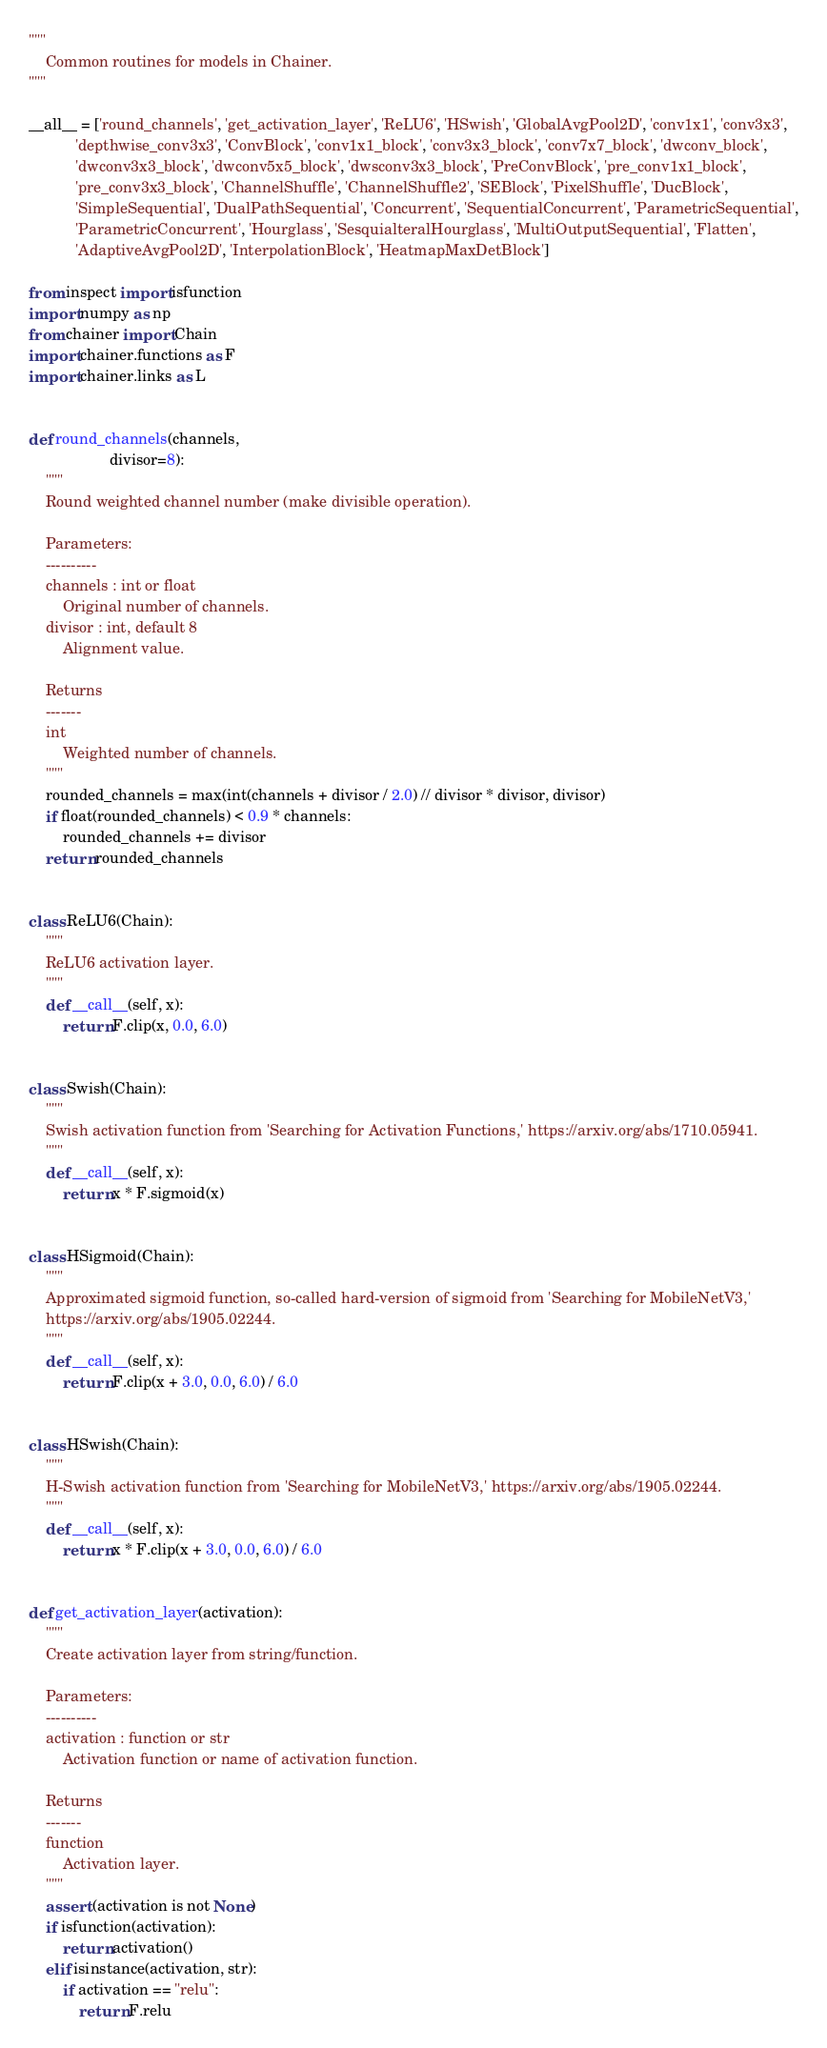<code> <loc_0><loc_0><loc_500><loc_500><_Python_>"""
    Common routines for models in Chainer.
"""

__all__ = ['round_channels', 'get_activation_layer', 'ReLU6', 'HSwish', 'GlobalAvgPool2D', 'conv1x1', 'conv3x3',
           'depthwise_conv3x3', 'ConvBlock', 'conv1x1_block', 'conv3x3_block', 'conv7x7_block', 'dwconv_block',
           'dwconv3x3_block', 'dwconv5x5_block', 'dwsconv3x3_block', 'PreConvBlock', 'pre_conv1x1_block',
           'pre_conv3x3_block', 'ChannelShuffle', 'ChannelShuffle2', 'SEBlock', 'PixelShuffle', 'DucBlock',
           'SimpleSequential', 'DualPathSequential', 'Concurrent', 'SequentialConcurrent', 'ParametricSequential',
           'ParametricConcurrent', 'Hourglass', 'SesquialteralHourglass', 'MultiOutputSequential', 'Flatten',
           'AdaptiveAvgPool2D', 'InterpolationBlock', 'HeatmapMaxDetBlock']

from inspect import isfunction
import numpy as np
from chainer import Chain
import chainer.functions as F
import chainer.links as L


def round_channels(channels,
                   divisor=8):
    """
    Round weighted channel number (make divisible operation).

    Parameters:
    ----------
    channels : int or float
        Original number of channels.
    divisor : int, default 8
        Alignment value.

    Returns
    -------
    int
        Weighted number of channels.
    """
    rounded_channels = max(int(channels + divisor / 2.0) // divisor * divisor, divisor)
    if float(rounded_channels) < 0.9 * channels:
        rounded_channels += divisor
    return rounded_channels


class ReLU6(Chain):
    """
    ReLU6 activation layer.
    """
    def __call__(self, x):
        return F.clip(x, 0.0, 6.0)


class Swish(Chain):
    """
    Swish activation function from 'Searching for Activation Functions,' https://arxiv.org/abs/1710.05941.
    """
    def __call__(self, x):
        return x * F.sigmoid(x)


class HSigmoid(Chain):
    """
    Approximated sigmoid function, so-called hard-version of sigmoid from 'Searching for MobileNetV3,'
    https://arxiv.org/abs/1905.02244.
    """
    def __call__(self, x):
        return F.clip(x + 3.0, 0.0, 6.0) / 6.0


class HSwish(Chain):
    """
    H-Swish activation function from 'Searching for MobileNetV3,' https://arxiv.org/abs/1905.02244.
    """
    def __call__(self, x):
        return x * F.clip(x + 3.0, 0.0, 6.0) / 6.0


def get_activation_layer(activation):
    """
    Create activation layer from string/function.

    Parameters:
    ----------
    activation : function or str
        Activation function or name of activation function.

    Returns
    -------
    function
        Activation layer.
    """
    assert (activation is not None)
    if isfunction(activation):
        return activation()
    elif isinstance(activation, str):
        if activation == "relu":
            return F.relu</code> 